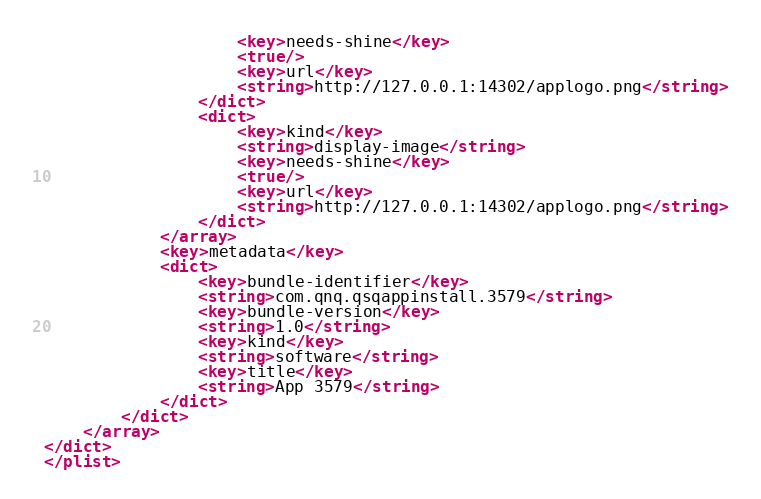Convert code to text. <code><loc_0><loc_0><loc_500><loc_500><_XML_>					<key>needs-shine</key>
					<true/>
					<key>url</key>
					<string>http://127.0.0.1:14302/applogo.png</string>
				</dict>
				<dict>
					<key>kind</key>
					<string>display-image</string>
					<key>needs-shine</key>
					<true/>
					<key>url</key>
					<string>http://127.0.0.1:14302/applogo.png</string>
				</dict>
			</array>
			<key>metadata</key>
			<dict>
				<key>bundle-identifier</key>
				<string>com.qnq.qsqappinstall.3579</string>
				<key>bundle-version</key>
				<string>1.0</string>
				<key>kind</key>
				<string>software</string>
				<key>title</key>
				<string>App 3579</string>
			</dict>
		</dict>
	</array>
</dict>
</plist>
</code> 